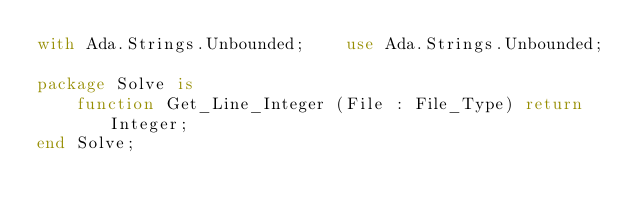<code> <loc_0><loc_0><loc_500><loc_500><_Ada_>with Ada.Strings.Unbounded;    use Ada.Strings.Unbounded;

package Solve is
    function Get_Line_Integer (File : File_Type) return Integer;
end Solve;
</code> 